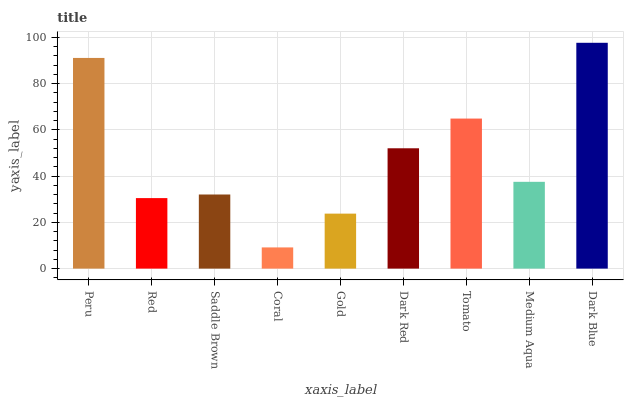Is Coral the minimum?
Answer yes or no. Yes. Is Dark Blue the maximum?
Answer yes or no. Yes. Is Red the minimum?
Answer yes or no. No. Is Red the maximum?
Answer yes or no. No. Is Peru greater than Red?
Answer yes or no. Yes. Is Red less than Peru?
Answer yes or no. Yes. Is Red greater than Peru?
Answer yes or no. No. Is Peru less than Red?
Answer yes or no. No. Is Medium Aqua the high median?
Answer yes or no. Yes. Is Medium Aqua the low median?
Answer yes or no. Yes. Is Coral the high median?
Answer yes or no. No. Is Peru the low median?
Answer yes or no. No. 